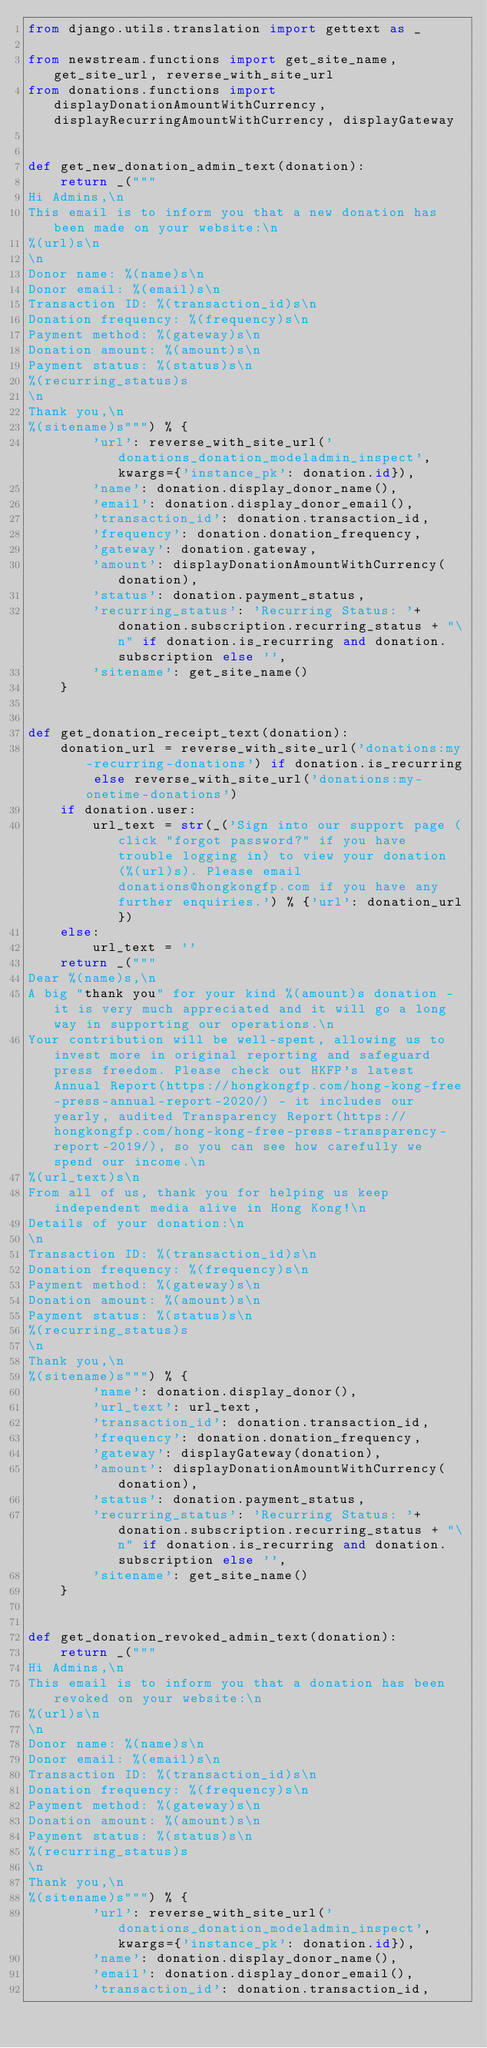<code> <loc_0><loc_0><loc_500><loc_500><_Python_>from django.utils.translation import gettext as _

from newstream.functions import get_site_name, get_site_url, reverse_with_site_url
from donations.functions import displayDonationAmountWithCurrency, displayRecurringAmountWithCurrency, displayGateway


def get_new_donation_admin_text(donation):
    return _("""
Hi Admins,\n
This email is to inform you that a new donation has been made on your website:\n
%(url)s\n
\n
Donor name: %(name)s\n
Donor email: %(email)s\n
Transaction ID: %(transaction_id)s\n
Donation frequency: %(frequency)s\n
Payment method: %(gateway)s\n
Donation amount: %(amount)s\n
Payment status: %(status)s\n
%(recurring_status)s
\n
Thank you,\n
%(sitename)s""") % {
        'url': reverse_with_site_url('donations_donation_modeladmin_inspect', kwargs={'instance_pk': donation.id}),
        'name': donation.display_donor_name(),
        'email': donation.display_donor_email(),
        'transaction_id': donation.transaction_id,
        'frequency': donation.donation_frequency,
        'gateway': donation.gateway,
        'amount': displayDonationAmountWithCurrency(donation),
        'status': donation.payment_status,
        'recurring_status': 'Recurring Status: '+donation.subscription.recurring_status + "\n" if donation.is_recurring and donation.subscription else '',
        'sitename': get_site_name()
    }


def get_donation_receipt_text(donation):
    donation_url = reverse_with_site_url('donations:my-recurring-donations') if donation.is_recurring else reverse_with_site_url('donations:my-onetime-donations')
    if donation.user:
        url_text = str(_('Sign into our support page (click "forgot password?" if you have trouble logging in) to view your donation(%(url)s). Please email donations@hongkongfp.com if you have any further enquiries.') % {'url': donation_url})
    else:
        url_text = ''
    return _("""
Dear %(name)s,\n
A big "thank you" for your kind %(amount)s donation - it is very much appreciated and it will go a long way in supporting our operations.\n
Your contribution will be well-spent, allowing us to invest more in original reporting and safeguard press freedom. Please check out HKFP's latest Annual Report(https://hongkongfp.com/hong-kong-free-press-annual-report-2020/) - it includes our yearly, audited Transparency Report(https://hongkongfp.com/hong-kong-free-press-transparency-report-2019/), so you can see how carefully we spend our income.\n
%(url_text)s\n
From all of us, thank you for helping us keep independent media alive in Hong Kong!\n
Details of your donation:\n
\n
Transaction ID: %(transaction_id)s\n
Donation frequency: %(frequency)s\n
Payment method: %(gateway)s\n
Donation amount: %(amount)s\n
Payment status: %(status)s\n
%(recurring_status)s
\n
Thank you,\n
%(sitename)s""") % {
        'name': donation.display_donor(),
        'url_text': url_text,
        'transaction_id': donation.transaction_id,
        'frequency': donation.donation_frequency,
        'gateway': displayGateway(donation),
        'amount': displayDonationAmountWithCurrency(donation),
        'status': donation.payment_status,
        'recurring_status': 'Recurring Status: '+donation.subscription.recurring_status + "\n" if donation.is_recurring and donation.subscription else '',
        'sitename': get_site_name()
    }


def get_donation_revoked_admin_text(donation):
    return _("""
Hi Admins,\n
This email is to inform you that a donation has been revoked on your website:\n
%(url)s\n
\n
Donor name: %(name)s\n
Donor email: %(email)s\n
Transaction ID: %(transaction_id)s\n
Donation frequency: %(frequency)s\n
Payment method: %(gateway)s\n
Donation amount: %(amount)s\n
Payment status: %(status)s\n
%(recurring_status)s
\n
Thank you,\n
%(sitename)s""") % {
        'url': reverse_with_site_url('donations_donation_modeladmin_inspect', kwargs={'instance_pk': donation.id}),
        'name': donation.display_donor_name(),
        'email': donation.display_donor_email(),
        'transaction_id': donation.transaction_id,</code> 